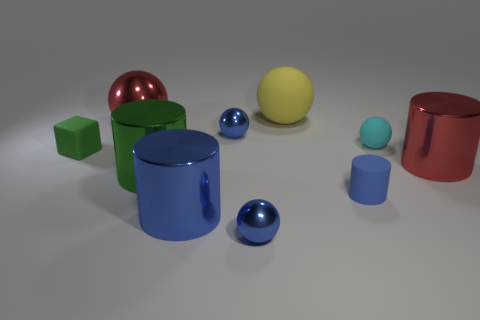If these objects were real, how might they be used in everyday life? If they were real physical objects, the cubes could serve as building blocks or decorative elements, the spheres as balls or decorative orbs, and the cylinders might function as containers, vases, or stands. Their vibrant colors and shiny surfaces would certainly make them stand out as part of modern decor or in educational settings for teaching geometry. 